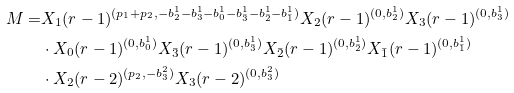<formula> <loc_0><loc_0><loc_500><loc_500>M = & X _ { 1 } ( r - 1 ) ^ { ( p _ { 1 } + p _ { 2 } , - b ^ { 1 } _ { 2 } - b ^ { 1 } _ { 3 } - b ^ { 1 } _ { 0 } - b ^ { 1 } _ { \bar { 3 } } - b ^ { 1 } _ { \bar { 2 } } - b ^ { 1 } _ { \bar { 1 } } ) } X _ { 2 } ( r - 1 ) ^ { ( 0 , b _ { 2 } ^ { 1 } ) } X _ { 3 } ( r - 1 ) ^ { ( 0 , b _ { 3 } ^ { 1 } ) } \\ & \cdot X _ { 0 } ( r - 1 ) ^ { ( 0 , b _ { 0 } ^ { 1 } ) } X _ { \bar { 3 } } ( r - 1 ) ^ { ( 0 , b _ { \bar { 3 } } ^ { 1 } ) } X _ { \bar { 2 } } ( r - 1 ) ^ { ( 0 , b _ { \bar { 2 } } ^ { 1 } ) } X _ { \bar { 1 } } ( r - 1 ) ^ { ( 0 , b _ { \bar { 1 } } ^ { 1 } ) } \\ & \cdot X _ { 2 } ( r - 2 ) ^ { ( p _ { 2 } , - b _ { 3 } ^ { 2 } ) } X _ { 3 } ( r - 2 ) ^ { ( 0 , b _ { 3 } ^ { 2 } ) }</formula> 